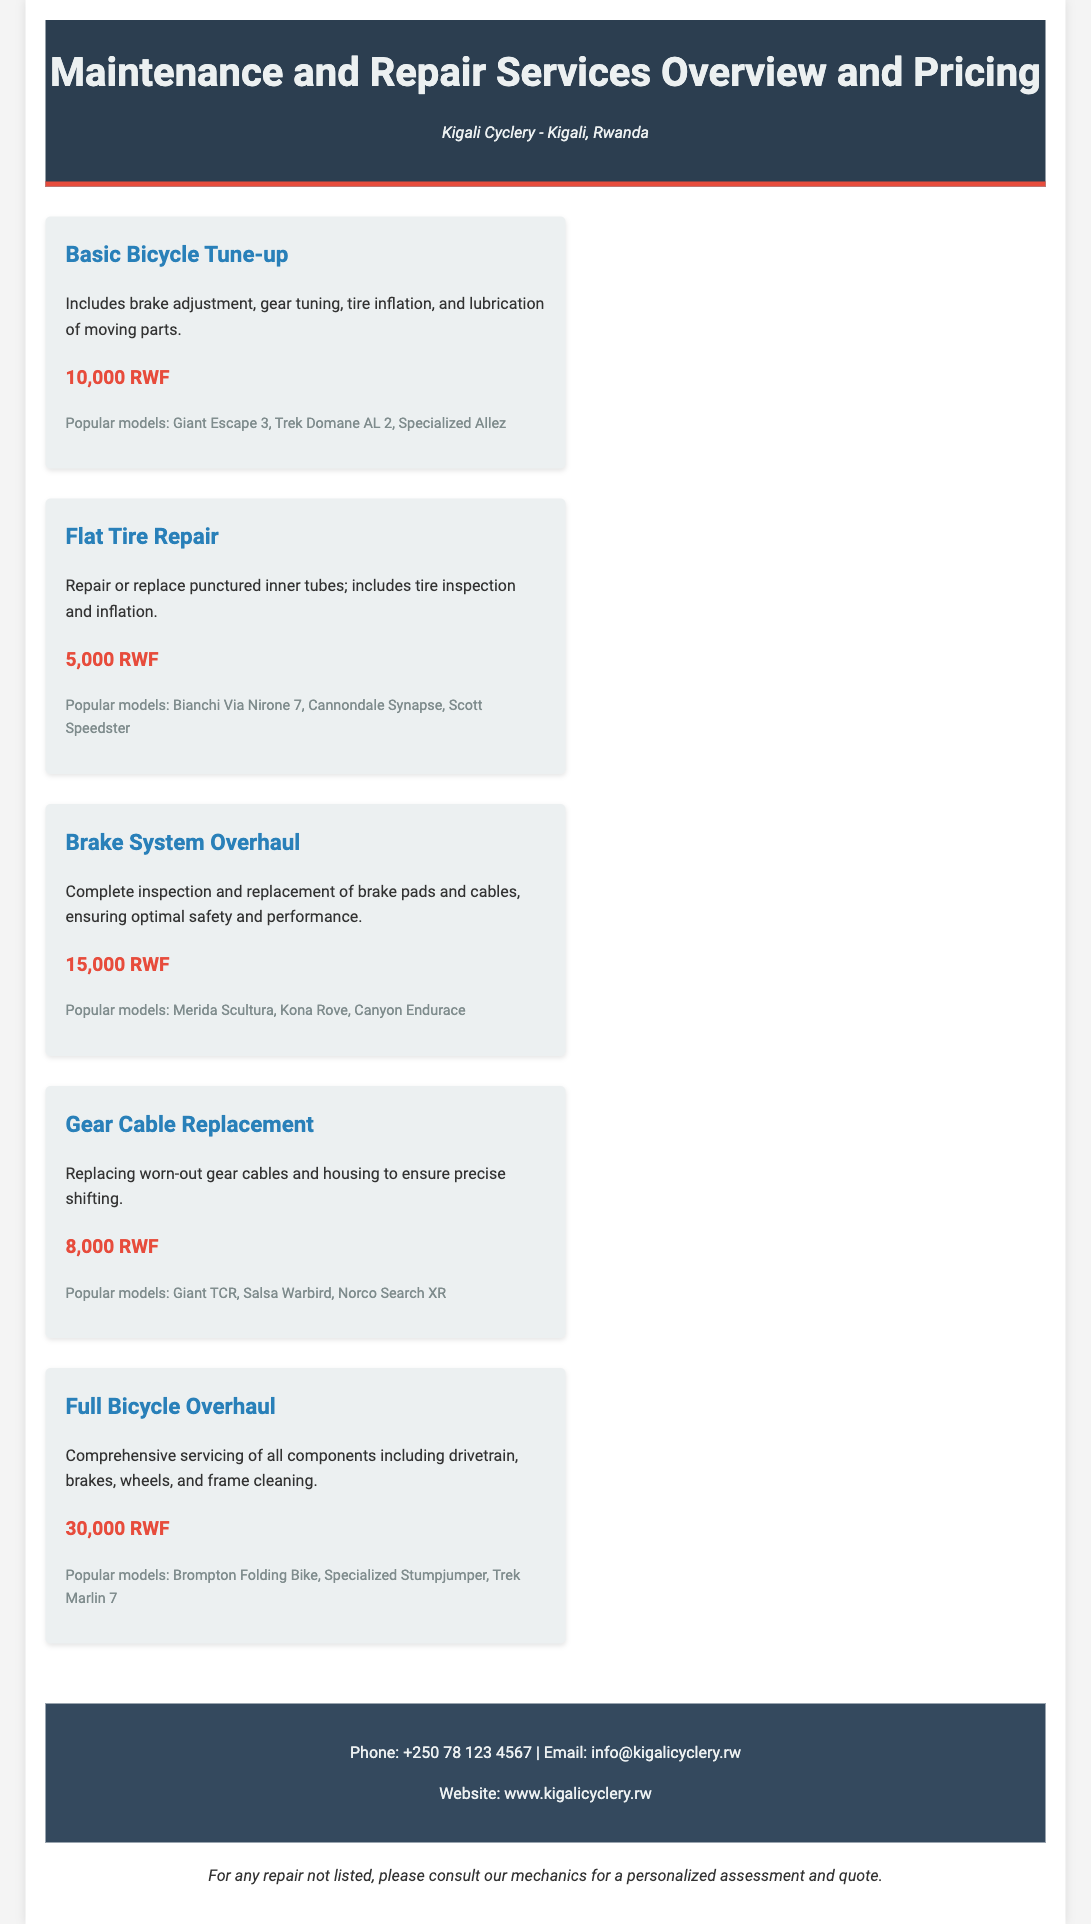What is the price of a Basic Bicycle Tune-up? The price for the Basic Bicycle Tune-up service is stated in the document.
Answer: 10,000 RWF What does the Flat Tire Repair service include? The Flat Tire Repair service includes specific activities as described in the document.
Answer: Repair or replace punctured inner tubes; includes tire inspection and inflation Which bicycle model is mentioned under the Brake System Overhaul service? The document lists popular bicycle models associated with each service, including one under Brake System Overhaul.
Answer: Merida Scultura What is the highest priced service in the catalog? The document lists different services along with their prices, identifying the highest one.
Answer: Full Bicycle Overhaul How much does a Gear Cable Replacement cost? The cost of the Gear Cable Replacement is given in the document.
Answer: 8,000 RWF Which service covers comprehensive servicing of all components? The description of services includes specific wording for comprehensive servicing, highlighting one in particular.
Answer: Full Bicycle Overhaul What is the contact phone number for Kigali Cyclery? The contact phone number for the shop is provided at the end of the document.
Answer: +250 78 123 4567 Which model is associated with the Flat Tire Repair service? The document provides a list of models for each service, including one for Flat Tire Repair.
Answer: Bianchi Via Nirone 7 What is the email address for inquiries? The document includes contact information such as email addresses for customers.
Answer: info@kigalicyclery.rw 